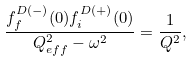Convert formula to latex. <formula><loc_0><loc_0><loc_500><loc_500>\frac { f ^ { D ( - ) } _ { f } ( { 0 } ) f ^ { D ( + ) } _ { i } ( { 0 } ) } { { Q } _ { e f f } ^ { 2 } - \omega ^ { 2 } } = \frac { 1 } { Q ^ { 2 } } ,</formula> 